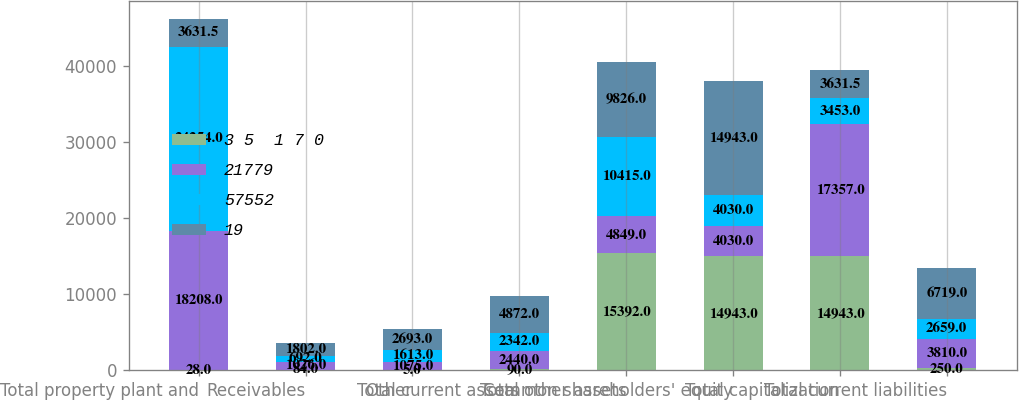Convert chart to OTSL. <chart><loc_0><loc_0><loc_500><loc_500><stacked_bar_chart><ecel><fcel>Total property plant and<fcel>Receivables<fcel>Other<fcel>Total current assets<fcel>Total other assets<fcel>Common shareholders' equity<fcel>Total capitalization<fcel>Total current liabilities<nl><fcel>3 5  1 7 0<fcel>28<fcel>84<fcel>5<fcel>90<fcel>15392<fcel>14943<fcel>14943<fcel>250<nl><fcel>21779<fcel>18208<fcel>1026<fcel>1075<fcel>2440<fcel>4849<fcel>4030<fcel>17357<fcel>3810<nl><fcel>57552<fcel>24254<fcel>692<fcel>1613<fcel>2342<fcel>10415<fcel>4030<fcel>3453<fcel>2659<nl><fcel>19<fcel>3631.5<fcel>1802<fcel>2693<fcel>4872<fcel>9826<fcel>14943<fcel>3631.5<fcel>6719<nl></chart> 